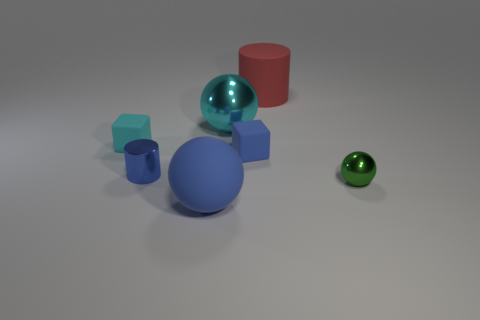What number of objects are cubes to the left of the cyan ball or big objects that are in front of the green sphere?
Make the answer very short. 2. Are there fewer blue spheres than small green rubber blocks?
Make the answer very short. No. What is the shape of the blue object that is the same size as the cyan shiny ball?
Provide a succinct answer. Sphere. How many other objects are there of the same color as the large metal sphere?
Offer a very short reply. 1. What number of small shiny things are there?
Give a very brief answer. 2. What number of metal balls are both to the left of the tiny blue matte object and to the right of the red matte object?
Your answer should be compact. 0. What is the material of the green ball?
Offer a terse response. Metal. Are any large brown metallic cubes visible?
Give a very brief answer. No. There is a large matte thing that is behind the blue metallic cylinder; what color is it?
Your answer should be very brief. Red. There is a big ball that is behind the sphere on the right side of the red object; what number of large matte objects are in front of it?
Your response must be concise. 1. 